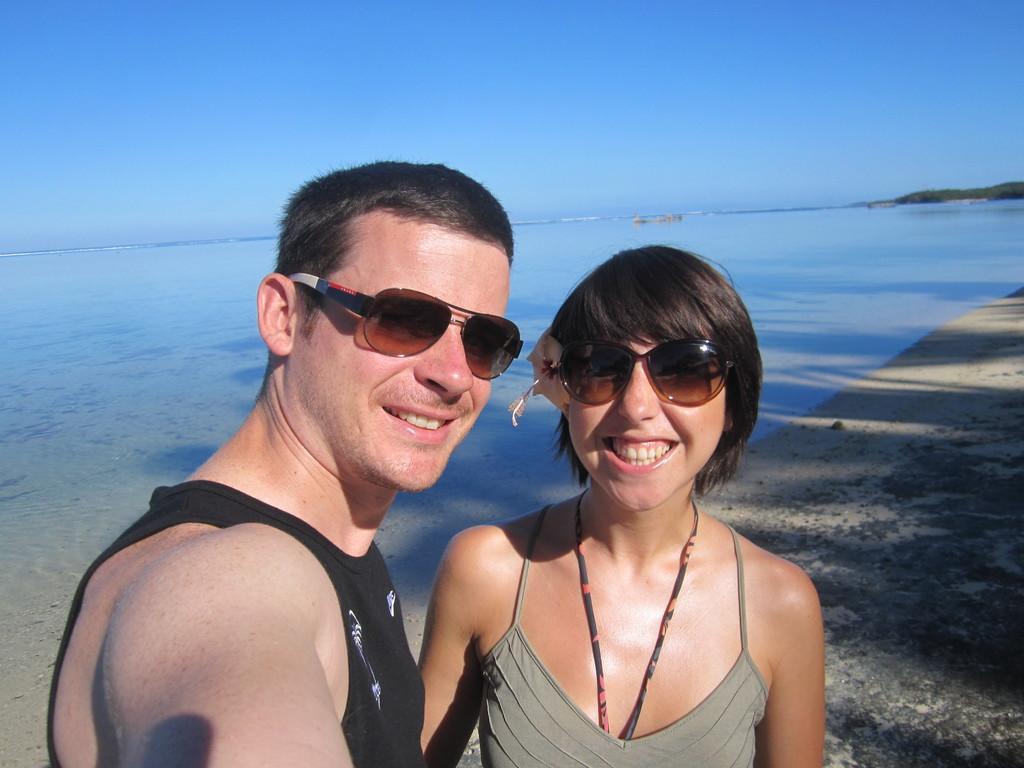In one or two sentences, can you explain what this image depicts? In this image there is a couple standing on the sea shore. Behind them there is water. At the top there is the sky. On the right side top it looks like an island. 